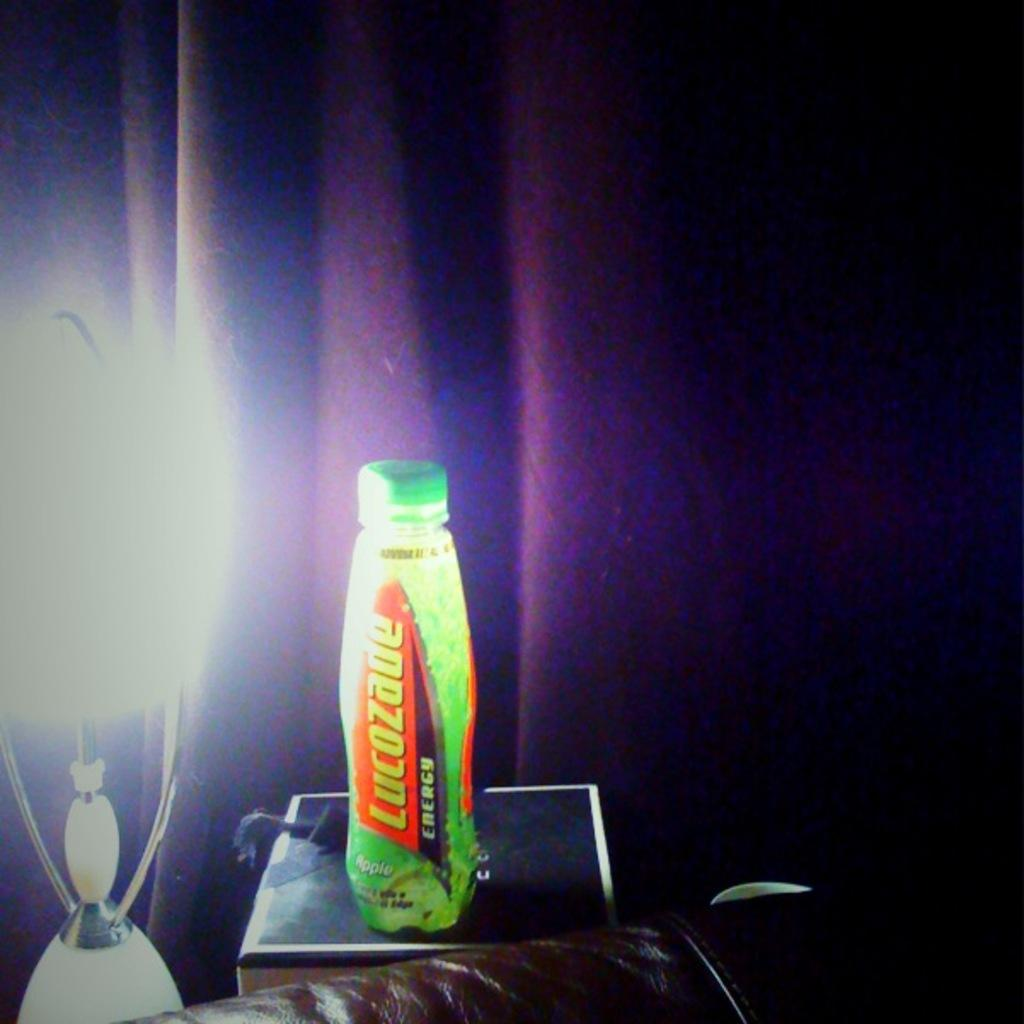Provide a one-sentence caption for the provided image. Lucozade energy drink sitting on a box next to a light. 